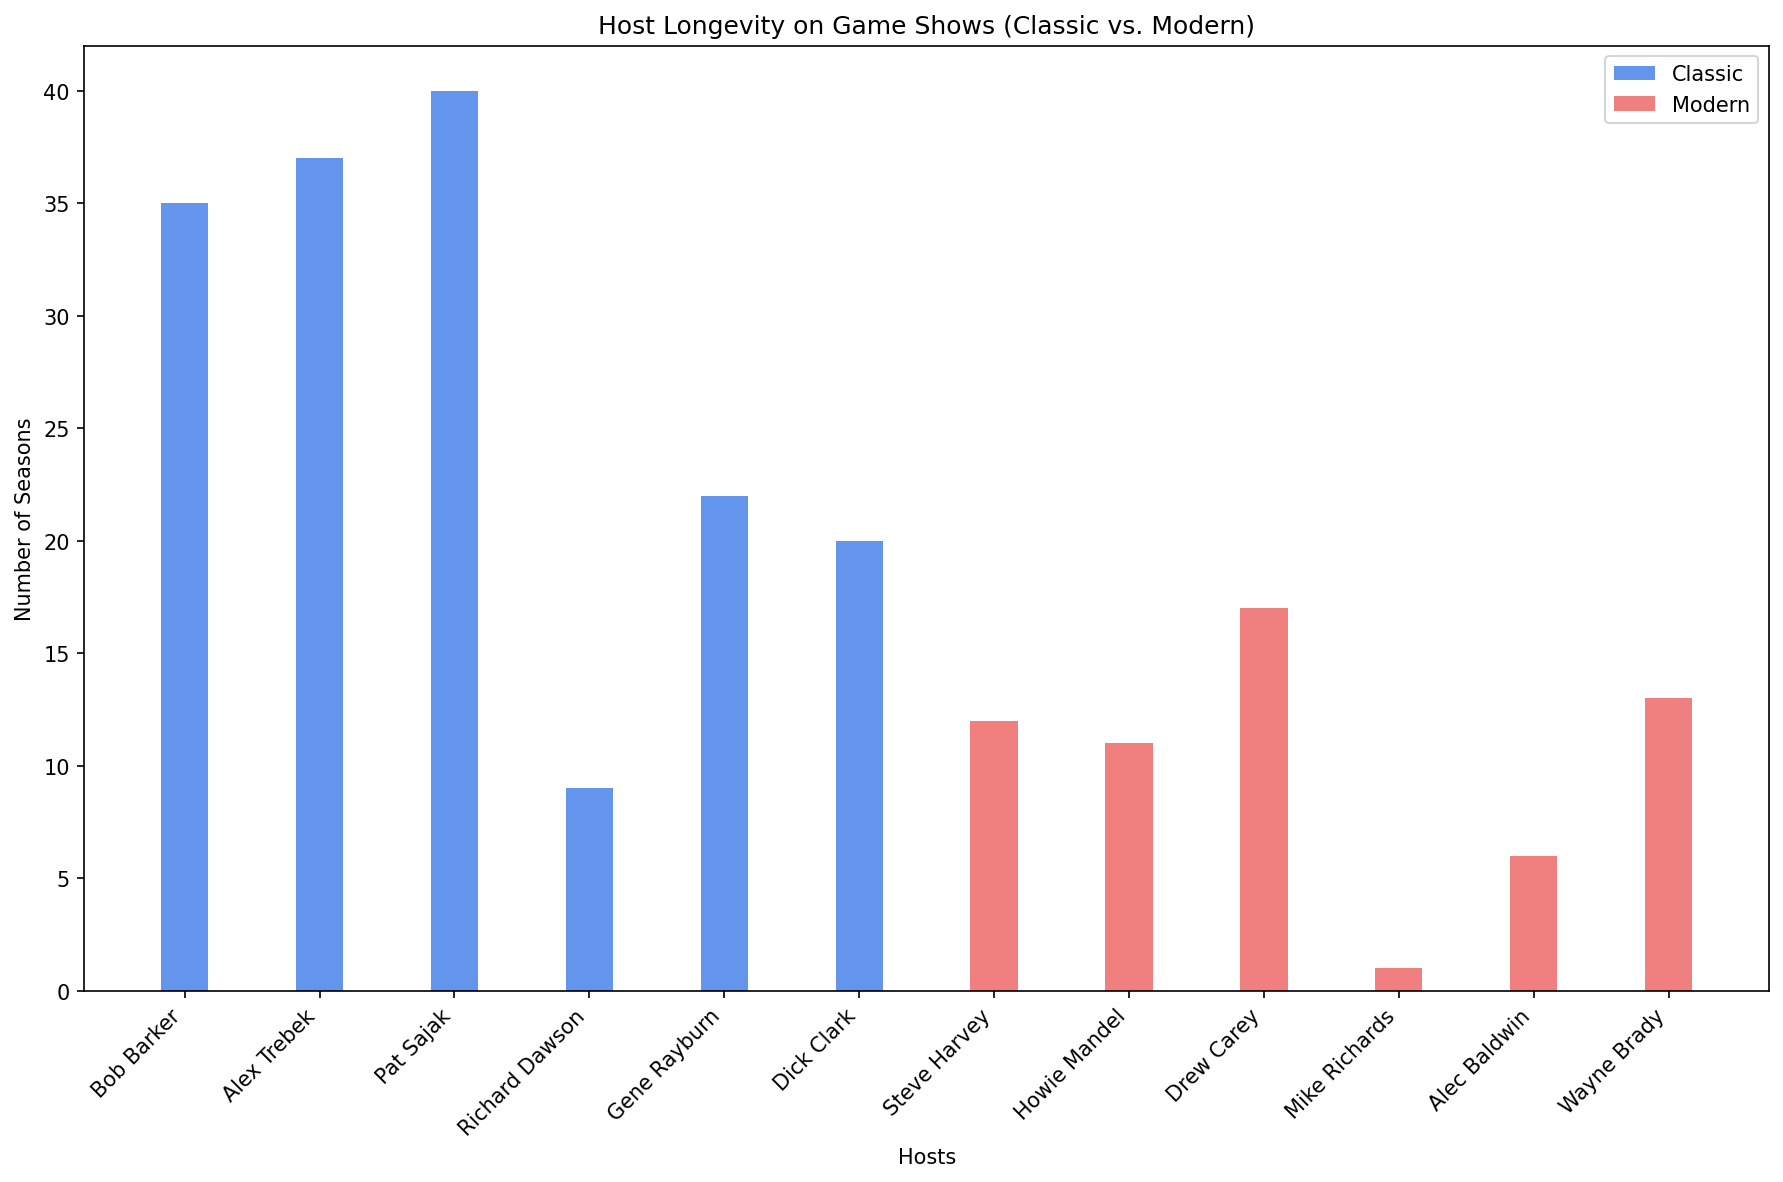Which host has the longest tenure on classic game shows? The bar that represents Pat Sajak is the tallest among the classic hosts, indicating the longest tenure.
Answer: Pat Sajak Which modern game show host has the shortest tenure? The bar representing Mike Richards is the shortest among the modern hosts.
Answer: Mike Richards How many more seasons did Pat Sajak host compared to Richard Dawson? Pat Sajak's bar shows 40 seasons, while Richard Dawson's bar shows 9 seasons. The difference is 40 - 9 = 31.
Answer: 31 What's the combined number of seasons hosted by Steve Harvey and Wayne Brady? Steve Harvey's bar shows 12 seasons and Wayne Brady's bar shows 13 seasons. The combined number is 12 + 13 = 25.
Answer: 25 Compare the tenure of Howie Mandel and Drew Carey. Who hosted more seasons and by how many? Drew Carey's bar shows 17 seasons, while Howie Mandel's bar shows 11 seasons. Drew Carey hosted 17 - 11 = 6 more seasons.
Answer: Drew Carey by 6 For the modern hosts, what's the average number of seasons hosted? The bars for modern hosts are 12, 11, 17, 1, 6, and 13. The total is 12 + 11 + 17 + 1 + 6 + 13 = 60 seasons. There are 6 modern hosts, so the average is 60 / 6 = 10.
Answer: 10 Whose bar in the classic hosts category is about half the height of Gene Rayburn's bar? Gene Rayburn's bar shows 22 seasons. Richard Dawson's bar shows 9 seasons, which is close to 11, about half of 22.
Answer: Richard Dawson Which category of hosts (classic or modern) has a greater total number of seasons? The bars for classic hosts show 35, 37, 40, 9, 22, and 20 seasons, totaling 163. The bars for modern hosts total 60 seasons. Classic hosts have a greater total number of seasons.
Answer: Classic hosts What color represents modern game show hosts? The bars for modern hosts are colored light red.
Answer: light red Between Bob Barker and Alex Trebek, who hosted for more seasons and by how many? Alex Trebek's bar shows 37 seasons, while Bob Barker's bar shows 35 seasons. Alex Trebek hosted 37 - 35 = 2 more seasons.
Answer: Alex Trebek by 2 